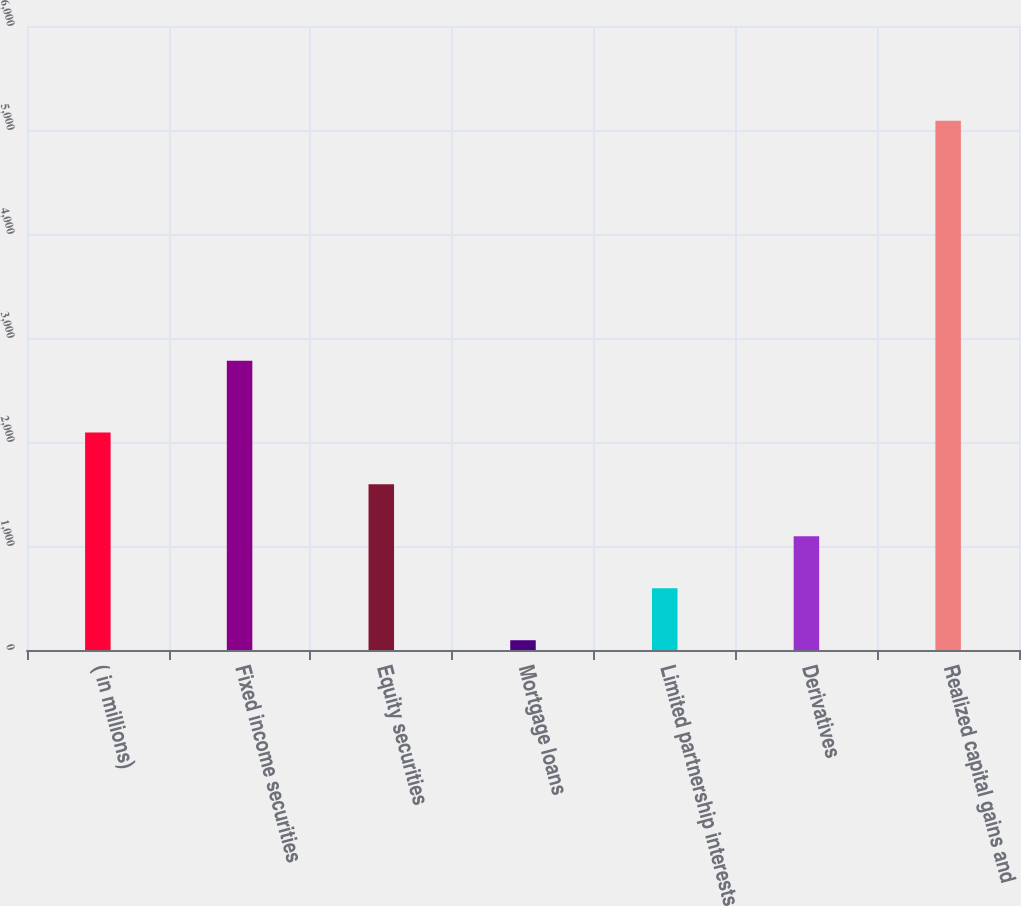Convert chart. <chart><loc_0><loc_0><loc_500><loc_500><bar_chart><fcel>( in millions)<fcel>Fixed income securities<fcel>Equity securities<fcel>Mortgage loans<fcel>Limited partnership interests<fcel>Derivatives<fcel>Realized capital gains and<nl><fcel>2092.4<fcel>2781<fcel>1592.8<fcel>94<fcel>593.6<fcel>1093.2<fcel>5090<nl></chart> 